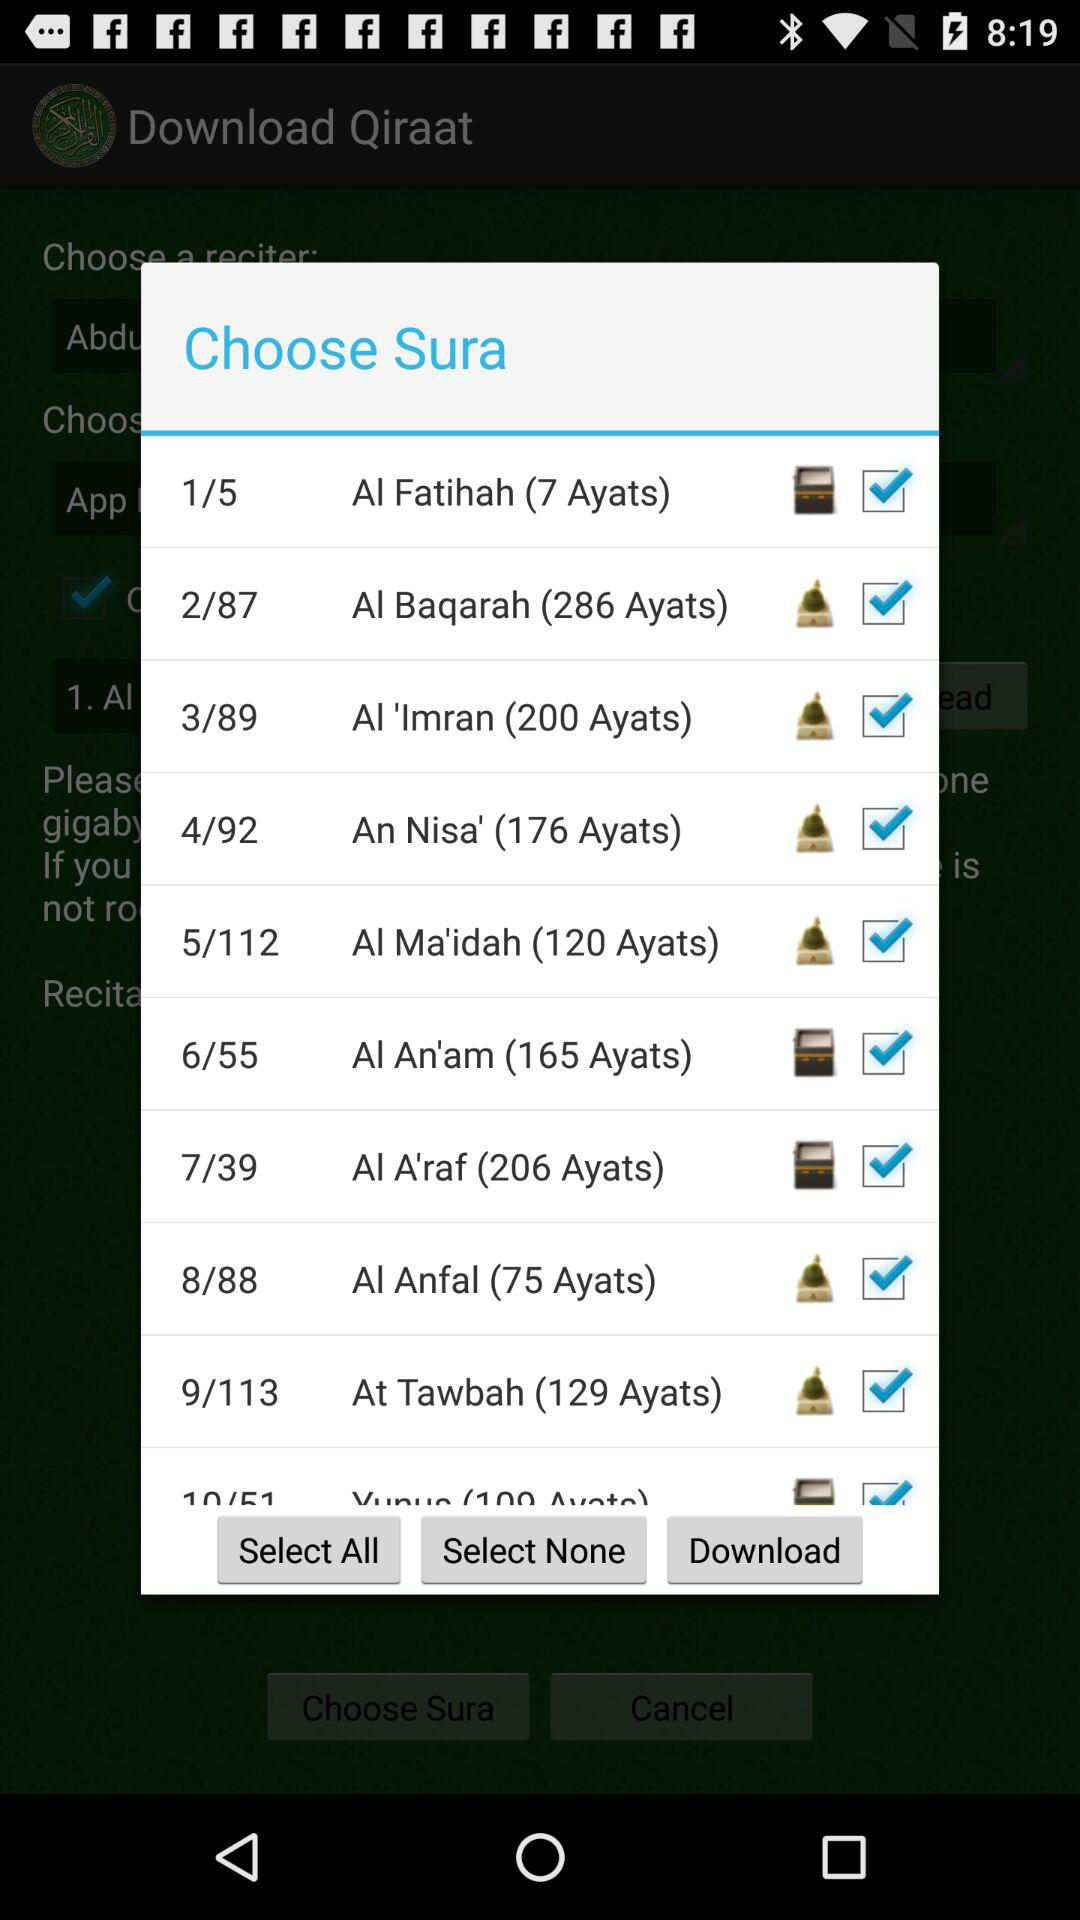How many ayats are in Al Anfal?
Answer the question using a single word or phrase. There are 75 Ayats in Al Anfal 